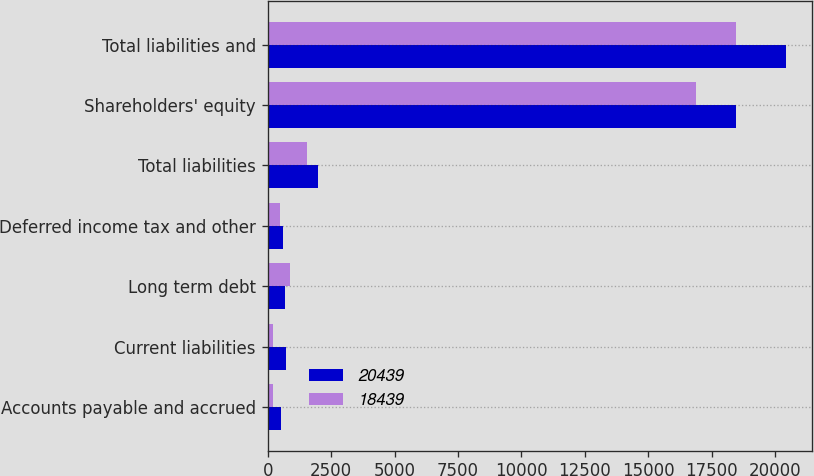Convert chart to OTSL. <chart><loc_0><loc_0><loc_500><loc_500><stacked_bar_chart><ecel><fcel>Accounts payable and accrued<fcel>Current liabilities<fcel>Long term debt<fcel>Deferred income tax and other<fcel>Total liabilities<fcel>Shareholders' equity<fcel>Total liabilities and<nl><fcel>20439<fcel>531<fcel>706<fcel>692<fcel>591<fcel>1989<fcel>18450<fcel>20439<nl><fcel>18439<fcel>202<fcel>202<fcel>867<fcel>471<fcel>1540<fcel>16899<fcel>18439<nl></chart> 